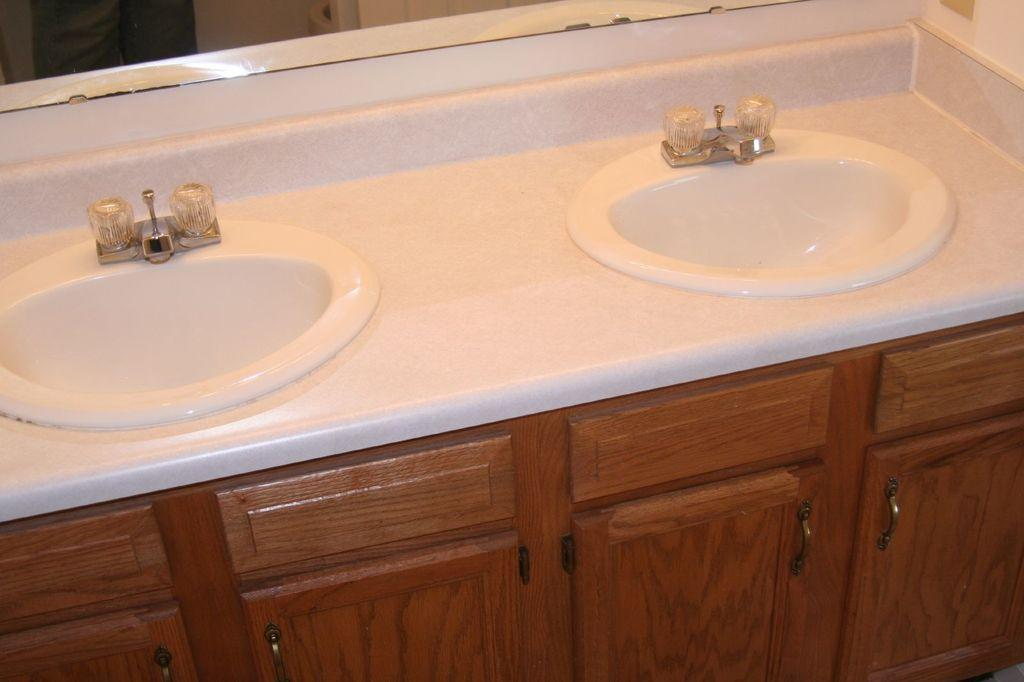How many sinks can be seen in the image? There are two white color sinks in the image. What is the color of the cupboards in the image? The cupboards in the image are brown color. What is present in the background of the image? There is a mirror visible in the background of the image. How many taps are there in the image? There are two taps in the image. What type of carriage is parked outside the room in the image? There is no carriage visible in the image; it only shows the sinks, cupboards, mirror, and taps. 